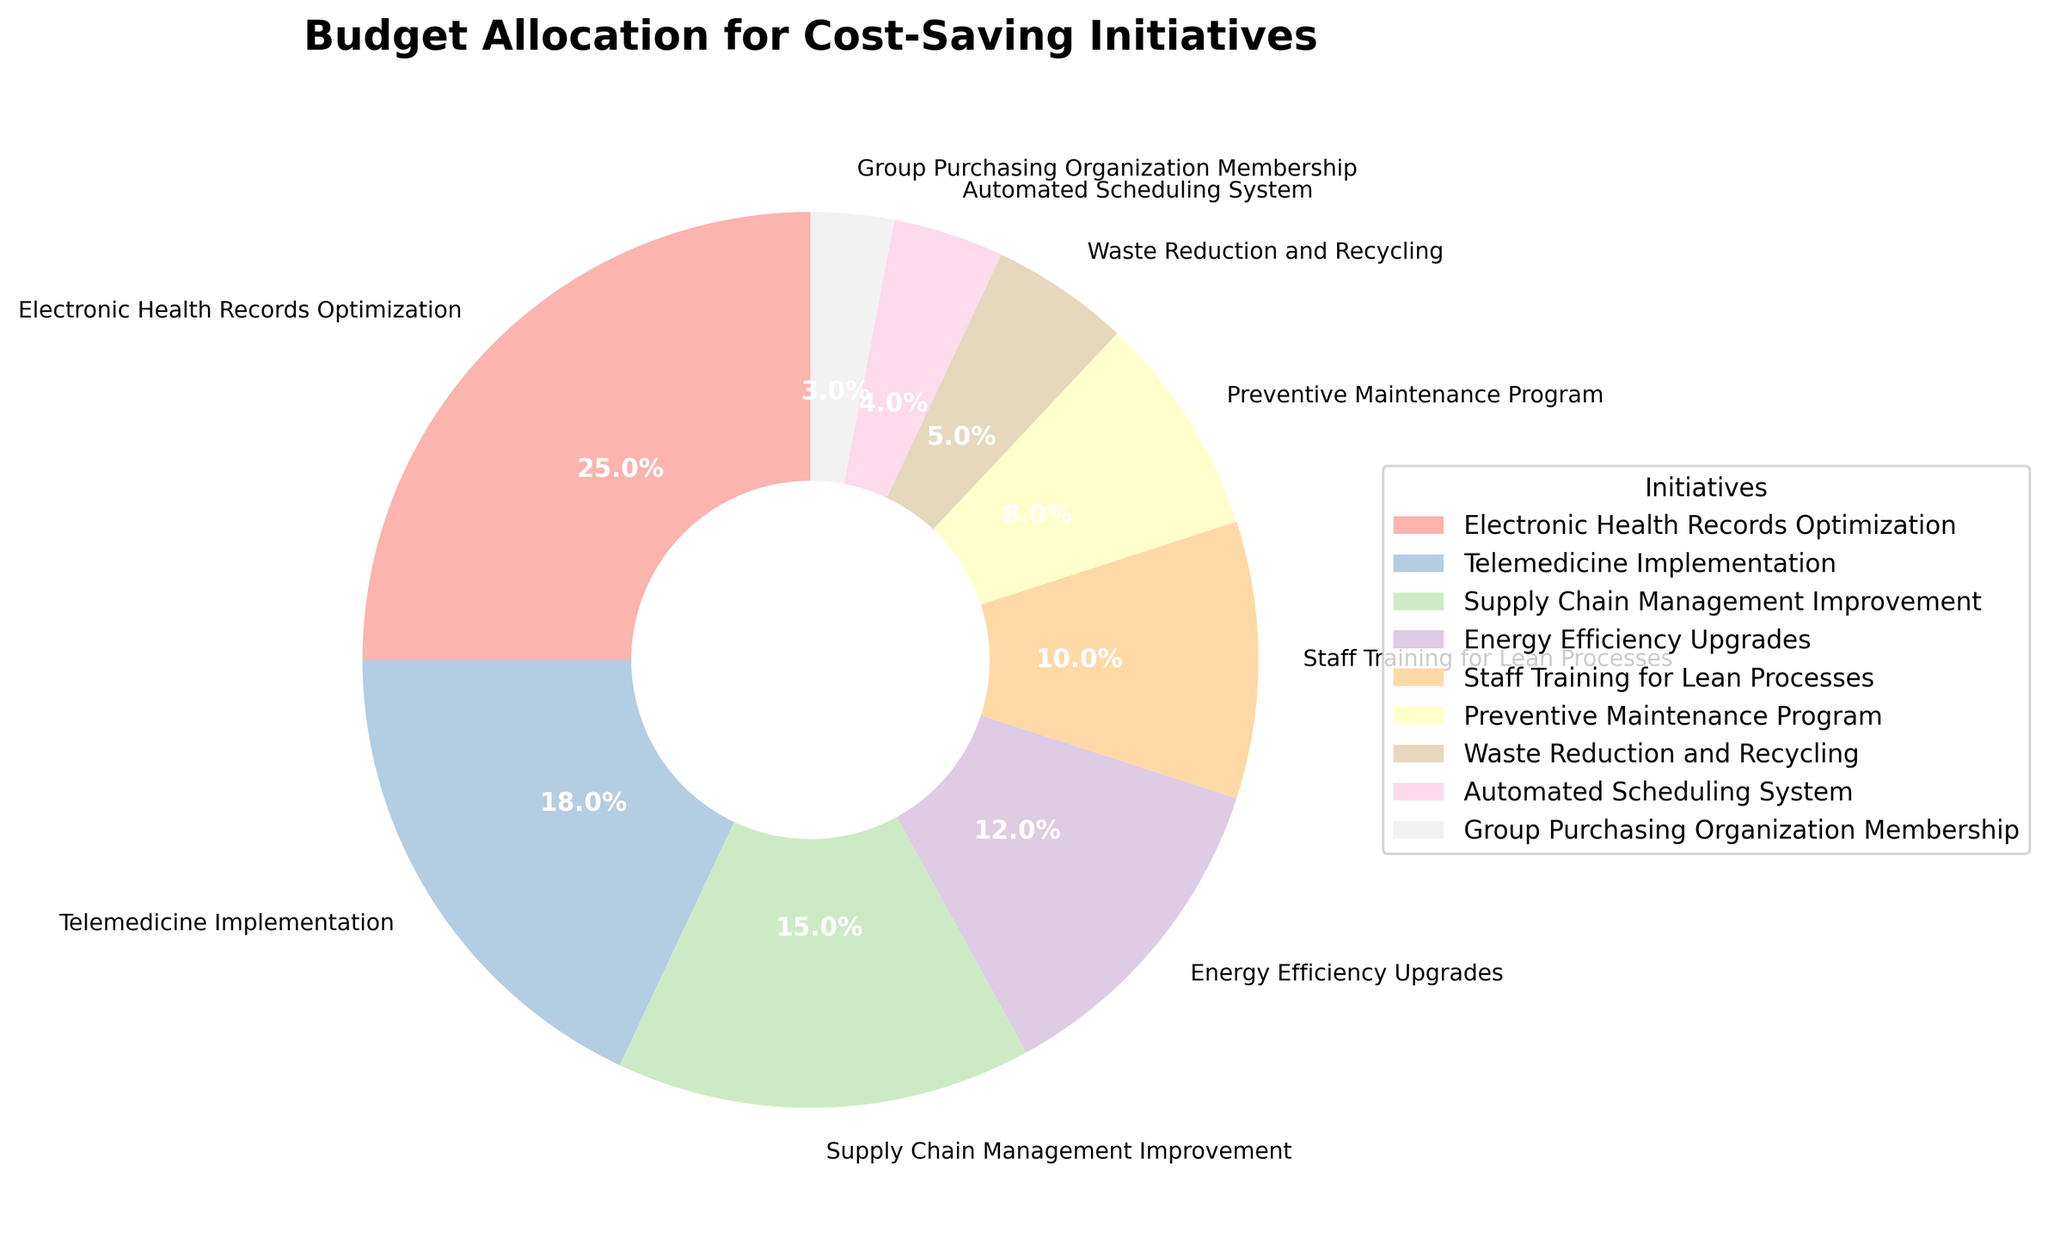What's the largest allocation in the budget? The wedge representing "Electronic Health Records Optimization" is the largest, and its label indicates a 25% allocation.
Answer: Electronic Health Records Optimization Which initiative has the lowest budget allocation? By looking at the smallest wedge segment in the pie chart, we see that "Group Purchasing Organization Membership" has the smallest slice, labeled as 3%.
Answer: Group Purchasing Organization Membership What is the combined budget allocation for "Telemedicine Implementation" and "Energy Efficiency Upgrades"? The pie chart lists "Telemedicine Implementation" at 18% and "Energy Efficiency Upgrades" at 12%. Adding these up, 18% + 12% equals 30%.
Answer: 30% Which budget allocation is larger: "Supply Chain Management Improvement" or "Staff Training for Lean Processes"? The chart shows "Supply Chain Management Improvement" is allocated 15% and "Staff Training for Lean Processes" is allocated 10%. Since 15% is greater than 10%, "Supply Chain Management Improvement" has the larger budget.
Answer: Supply Chain Management Improvement What's the total budget allocation for initiatives related to staff improvements ("Staff Training for Lean Processes" and "Automated Scheduling System")? The chart lists "Staff Training for Lean Processes" at 10% and "Automated Scheduling System" at 4%. Adding these together, 10% + 4% equals 14%.
Answer: 14% How much more percentage is allocated to "Preventive Maintenance Program" compared to "Waste Reduction and Recycling"? "Preventive Maintenance Program" is allocated 8% and "Waste Reduction and Recycling" is allocated 5%. The difference is 8% - 5%, which equals 3%.
Answer: 3% What is the average budget allocation for all the initiatives listed? The total budget allocation is the sum of the percentages: 25% + 18% + 15% + 12% + 10% + 8% + 5% + 4% + 3%. This equals 100%. There are 9 initiatives, so the average budget allocation is 100%/9, which is approximately 11.1%.
Answer: 11.1% What visual cue helps most in understanding the significance of each initiative's allocation? The size of each wedge in the pie chart serves as the visual cue, representing the percentage of the budget allocated to each initiative. Larger wedges indicate higher allocations.
Answer: Size of each wedge 